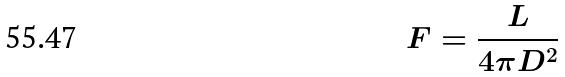<formula> <loc_0><loc_0><loc_500><loc_500>F = \frac { L } { 4 \pi D ^ { 2 } }</formula> 